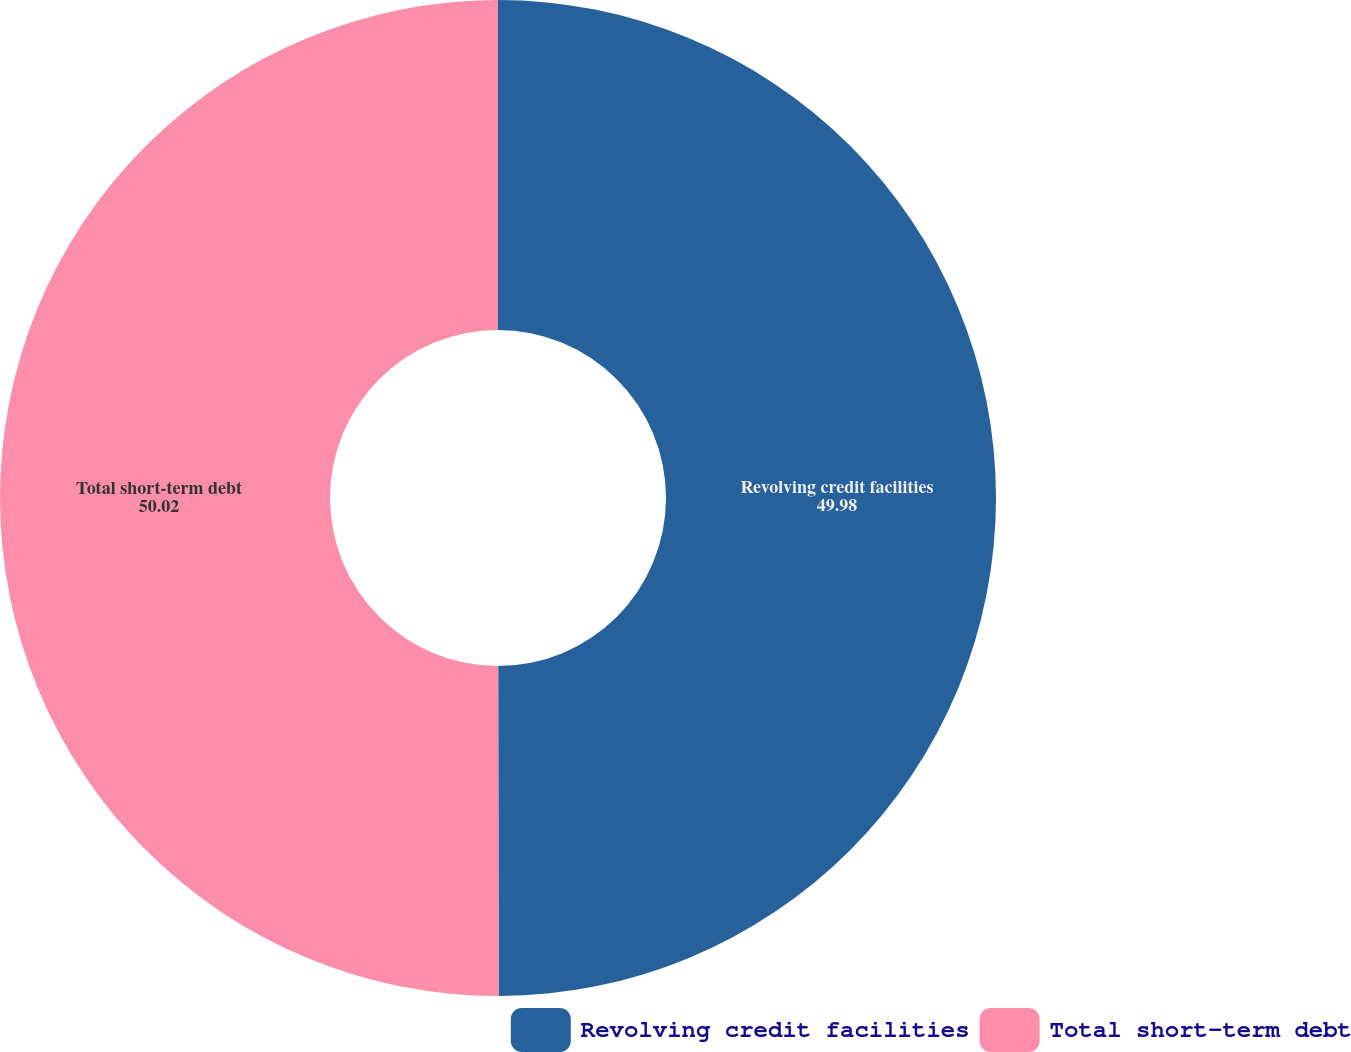<chart> <loc_0><loc_0><loc_500><loc_500><pie_chart><fcel>Revolving credit facilities<fcel>Total short-term debt<nl><fcel>49.98%<fcel>50.02%<nl></chart> 